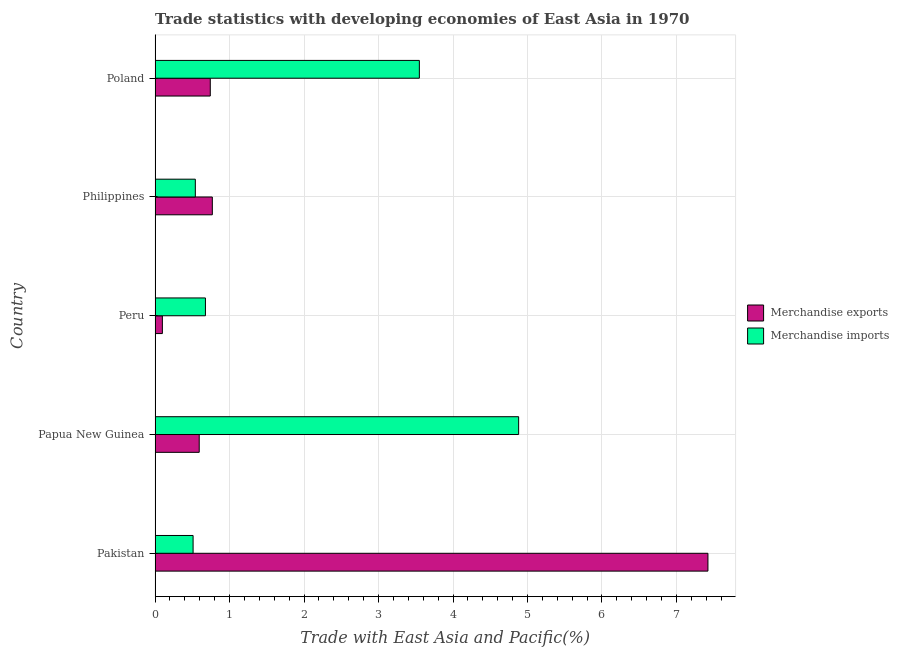How many bars are there on the 5th tick from the top?
Ensure brevity in your answer.  2. What is the merchandise imports in Pakistan?
Provide a short and direct response. 0.51. Across all countries, what is the maximum merchandise imports?
Your answer should be compact. 4.88. Across all countries, what is the minimum merchandise exports?
Your answer should be compact. 0.1. In which country was the merchandise imports maximum?
Provide a short and direct response. Papua New Guinea. What is the total merchandise exports in the graph?
Your response must be concise. 9.62. What is the difference between the merchandise exports in Pakistan and that in Poland?
Keep it short and to the point. 6.68. What is the difference between the merchandise imports in Philippines and the merchandise exports in Poland?
Your response must be concise. -0.2. What is the average merchandise imports per country?
Your response must be concise. 2.03. What is the difference between the merchandise imports and merchandise exports in Philippines?
Give a very brief answer. -0.23. What is the ratio of the merchandise exports in Pakistan to that in Philippines?
Offer a very short reply. 9.65. What is the difference between the highest and the second highest merchandise exports?
Make the answer very short. 6.65. What is the difference between the highest and the lowest merchandise exports?
Provide a short and direct response. 7.32. Are all the bars in the graph horizontal?
Provide a short and direct response. Yes. Are the values on the major ticks of X-axis written in scientific E-notation?
Offer a very short reply. No. How many legend labels are there?
Your response must be concise. 2. How are the legend labels stacked?
Your response must be concise. Vertical. What is the title of the graph?
Offer a terse response. Trade statistics with developing economies of East Asia in 1970. Does "Male entrants" appear as one of the legend labels in the graph?
Give a very brief answer. No. What is the label or title of the X-axis?
Offer a terse response. Trade with East Asia and Pacific(%). What is the label or title of the Y-axis?
Give a very brief answer. Country. What is the Trade with East Asia and Pacific(%) in Merchandise exports in Pakistan?
Your answer should be very brief. 7.42. What is the Trade with East Asia and Pacific(%) of Merchandise imports in Pakistan?
Your answer should be compact. 0.51. What is the Trade with East Asia and Pacific(%) of Merchandise exports in Papua New Guinea?
Your answer should be very brief. 0.59. What is the Trade with East Asia and Pacific(%) of Merchandise imports in Papua New Guinea?
Provide a short and direct response. 4.88. What is the Trade with East Asia and Pacific(%) in Merchandise exports in Peru?
Your response must be concise. 0.1. What is the Trade with East Asia and Pacific(%) of Merchandise imports in Peru?
Provide a short and direct response. 0.68. What is the Trade with East Asia and Pacific(%) of Merchandise exports in Philippines?
Offer a very short reply. 0.77. What is the Trade with East Asia and Pacific(%) in Merchandise imports in Philippines?
Offer a terse response. 0.54. What is the Trade with East Asia and Pacific(%) of Merchandise exports in Poland?
Your answer should be compact. 0.74. What is the Trade with East Asia and Pacific(%) of Merchandise imports in Poland?
Ensure brevity in your answer.  3.55. Across all countries, what is the maximum Trade with East Asia and Pacific(%) in Merchandise exports?
Keep it short and to the point. 7.42. Across all countries, what is the maximum Trade with East Asia and Pacific(%) in Merchandise imports?
Keep it short and to the point. 4.88. Across all countries, what is the minimum Trade with East Asia and Pacific(%) of Merchandise exports?
Your response must be concise. 0.1. Across all countries, what is the minimum Trade with East Asia and Pacific(%) of Merchandise imports?
Ensure brevity in your answer.  0.51. What is the total Trade with East Asia and Pacific(%) in Merchandise exports in the graph?
Your response must be concise. 9.62. What is the total Trade with East Asia and Pacific(%) of Merchandise imports in the graph?
Your answer should be very brief. 10.16. What is the difference between the Trade with East Asia and Pacific(%) of Merchandise exports in Pakistan and that in Papua New Guinea?
Your answer should be very brief. 6.83. What is the difference between the Trade with East Asia and Pacific(%) in Merchandise imports in Pakistan and that in Papua New Guinea?
Your answer should be compact. -4.37. What is the difference between the Trade with East Asia and Pacific(%) in Merchandise exports in Pakistan and that in Peru?
Provide a succinct answer. 7.32. What is the difference between the Trade with East Asia and Pacific(%) in Merchandise imports in Pakistan and that in Peru?
Your answer should be compact. -0.17. What is the difference between the Trade with East Asia and Pacific(%) in Merchandise exports in Pakistan and that in Philippines?
Offer a terse response. 6.65. What is the difference between the Trade with East Asia and Pacific(%) in Merchandise imports in Pakistan and that in Philippines?
Offer a terse response. -0.03. What is the difference between the Trade with East Asia and Pacific(%) of Merchandise exports in Pakistan and that in Poland?
Make the answer very short. 6.68. What is the difference between the Trade with East Asia and Pacific(%) of Merchandise imports in Pakistan and that in Poland?
Ensure brevity in your answer.  -3.04. What is the difference between the Trade with East Asia and Pacific(%) in Merchandise exports in Papua New Guinea and that in Peru?
Give a very brief answer. 0.49. What is the difference between the Trade with East Asia and Pacific(%) in Merchandise imports in Papua New Guinea and that in Peru?
Give a very brief answer. 4.2. What is the difference between the Trade with East Asia and Pacific(%) of Merchandise exports in Papua New Guinea and that in Philippines?
Ensure brevity in your answer.  -0.18. What is the difference between the Trade with East Asia and Pacific(%) of Merchandise imports in Papua New Guinea and that in Philippines?
Provide a succinct answer. 4.34. What is the difference between the Trade with East Asia and Pacific(%) in Merchandise exports in Papua New Guinea and that in Poland?
Make the answer very short. -0.15. What is the difference between the Trade with East Asia and Pacific(%) in Merchandise imports in Papua New Guinea and that in Poland?
Keep it short and to the point. 1.33. What is the difference between the Trade with East Asia and Pacific(%) in Merchandise exports in Peru and that in Philippines?
Your response must be concise. -0.67. What is the difference between the Trade with East Asia and Pacific(%) of Merchandise imports in Peru and that in Philippines?
Provide a short and direct response. 0.14. What is the difference between the Trade with East Asia and Pacific(%) in Merchandise exports in Peru and that in Poland?
Give a very brief answer. -0.64. What is the difference between the Trade with East Asia and Pacific(%) in Merchandise imports in Peru and that in Poland?
Your answer should be very brief. -2.87. What is the difference between the Trade with East Asia and Pacific(%) of Merchandise exports in Philippines and that in Poland?
Your answer should be very brief. 0.03. What is the difference between the Trade with East Asia and Pacific(%) of Merchandise imports in Philippines and that in Poland?
Ensure brevity in your answer.  -3.01. What is the difference between the Trade with East Asia and Pacific(%) in Merchandise exports in Pakistan and the Trade with East Asia and Pacific(%) in Merchandise imports in Papua New Guinea?
Offer a terse response. 2.54. What is the difference between the Trade with East Asia and Pacific(%) in Merchandise exports in Pakistan and the Trade with East Asia and Pacific(%) in Merchandise imports in Peru?
Offer a very short reply. 6.75. What is the difference between the Trade with East Asia and Pacific(%) of Merchandise exports in Pakistan and the Trade with East Asia and Pacific(%) of Merchandise imports in Philippines?
Provide a short and direct response. 6.88. What is the difference between the Trade with East Asia and Pacific(%) of Merchandise exports in Pakistan and the Trade with East Asia and Pacific(%) of Merchandise imports in Poland?
Provide a succinct answer. 3.87. What is the difference between the Trade with East Asia and Pacific(%) of Merchandise exports in Papua New Guinea and the Trade with East Asia and Pacific(%) of Merchandise imports in Peru?
Offer a very short reply. -0.08. What is the difference between the Trade with East Asia and Pacific(%) in Merchandise exports in Papua New Guinea and the Trade with East Asia and Pacific(%) in Merchandise imports in Philippines?
Offer a very short reply. 0.05. What is the difference between the Trade with East Asia and Pacific(%) in Merchandise exports in Papua New Guinea and the Trade with East Asia and Pacific(%) in Merchandise imports in Poland?
Offer a terse response. -2.96. What is the difference between the Trade with East Asia and Pacific(%) of Merchandise exports in Peru and the Trade with East Asia and Pacific(%) of Merchandise imports in Philippines?
Offer a terse response. -0.44. What is the difference between the Trade with East Asia and Pacific(%) in Merchandise exports in Peru and the Trade with East Asia and Pacific(%) in Merchandise imports in Poland?
Make the answer very short. -3.45. What is the difference between the Trade with East Asia and Pacific(%) in Merchandise exports in Philippines and the Trade with East Asia and Pacific(%) in Merchandise imports in Poland?
Keep it short and to the point. -2.78. What is the average Trade with East Asia and Pacific(%) of Merchandise exports per country?
Your response must be concise. 1.92. What is the average Trade with East Asia and Pacific(%) of Merchandise imports per country?
Provide a short and direct response. 2.03. What is the difference between the Trade with East Asia and Pacific(%) in Merchandise exports and Trade with East Asia and Pacific(%) in Merchandise imports in Pakistan?
Provide a short and direct response. 6.91. What is the difference between the Trade with East Asia and Pacific(%) of Merchandise exports and Trade with East Asia and Pacific(%) of Merchandise imports in Papua New Guinea?
Offer a terse response. -4.29. What is the difference between the Trade with East Asia and Pacific(%) of Merchandise exports and Trade with East Asia and Pacific(%) of Merchandise imports in Peru?
Offer a very short reply. -0.58. What is the difference between the Trade with East Asia and Pacific(%) of Merchandise exports and Trade with East Asia and Pacific(%) of Merchandise imports in Philippines?
Your response must be concise. 0.23. What is the difference between the Trade with East Asia and Pacific(%) of Merchandise exports and Trade with East Asia and Pacific(%) of Merchandise imports in Poland?
Provide a short and direct response. -2.81. What is the ratio of the Trade with East Asia and Pacific(%) of Merchandise exports in Pakistan to that in Papua New Guinea?
Your answer should be very brief. 12.52. What is the ratio of the Trade with East Asia and Pacific(%) of Merchandise imports in Pakistan to that in Papua New Guinea?
Your response must be concise. 0.1. What is the ratio of the Trade with East Asia and Pacific(%) in Merchandise exports in Pakistan to that in Peru?
Provide a short and direct response. 75.51. What is the ratio of the Trade with East Asia and Pacific(%) in Merchandise imports in Pakistan to that in Peru?
Offer a terse response. 0.75. What is the ratio of the Trade with East Asia and Pacific(%) in Merchandise exports in Pakistan to that in Philippines?
Your response must be concise. 9.65. What is the ratio of the Trade with East Asia and Pacific(%) in Merchandise imports in Pakistan to that in Philippines?
Your answer should be very brief. 0.94. What is the ratio of the Trade with East Asia and Pacific(%) in Merchandise exports in Pakistan to that in Poland?
Offer a terse response. 10.01. What is the ratio of the Trade with East Asia and Pacific(%) of Merchandise imports in Pakistan to that in Poland?
Keep it short and to the point. 0.14. What is the ratio of the Trade with East Asia and Pacific(%) of Merchandise exports in Papua New Guinea to that in Peru?
Provide a succinct answer. 6.03. What is the ratio of the Trade with East Asia and Pacific(%) of Merchandise imports in Papua New Guinea to that in Peru?
Provide a succinct answer. 7.22. What is the ratio of the Trade with East Asia and Pacific(%) in Merchandise exports in Papua New Guinea to that in Philippines?
Offer a terse response. 0.77. What is the ratio of the Trade with East Asia and Pacific(%) in Merchandise imports in Papua New Guinea to that in Philippines?
Make the answer very short. 9.03. What is the ratio of the Trade with East Asia and Pacific(%) of Merchandise exports in Papua New Guinea to that in Poland?
Your response must be concise. 0.8. What is the ratio of the Trade with East Asia and Pacific(%) of Merchandise imports in Papua New Guinea to that in Poland?
Provide a succinct answer. 1.38. What is the ratio of the Trade with East Asia and Pacific(%) in Merchandise exports in Peru to that in Philippines?
Make the answer very short. 0.13. What is the ratio of the Trade with East Asia and Pacific(%) of Merchandise imports in Peru to that in Philippines?
Your response must be concise. 1.25. What is the ratio of the Trade with East Asia and Pacific(%) in Merchandise exports in Peru to that in Poland?
Offer a terse response. 0.13. What is the ratio of the Trade with East Asia and Pacific(%) in Merchandise imports in Peru to that in Poland?
Your response must be concise. 0.19. What is the ratio of the Trade with East Asia and Pacific(%) of Merchandise exports in Philippines to that in Poland?
Give a very brief answer. 1.04. What is the ratio of the Trade with East Asia and Pacific(%) of Merchandise imports in Philippines to that in Poland?
Ensure brevity in your answer.  0.15. What is the difference between the highest and the second highest Trade with East Asia and Pacific(%) in Merchandise exports?
Provide a short and direct response. 6.65. What is the difference between the highest and the second highest Trade with East Asia and Pacific(%) in Merchandise imports?
Give a very brief answer. 1.33. What is the difference between the highest and the lowest Trade with East Asia and Pacific(%) of Merchandise exports?
Make the answer very short. 7.32. What is the difference between the highest and the lowest Trade with East Asia and Pacific(%) in Merchandise imports?
Ensure brevity in your answer.  4.37. 